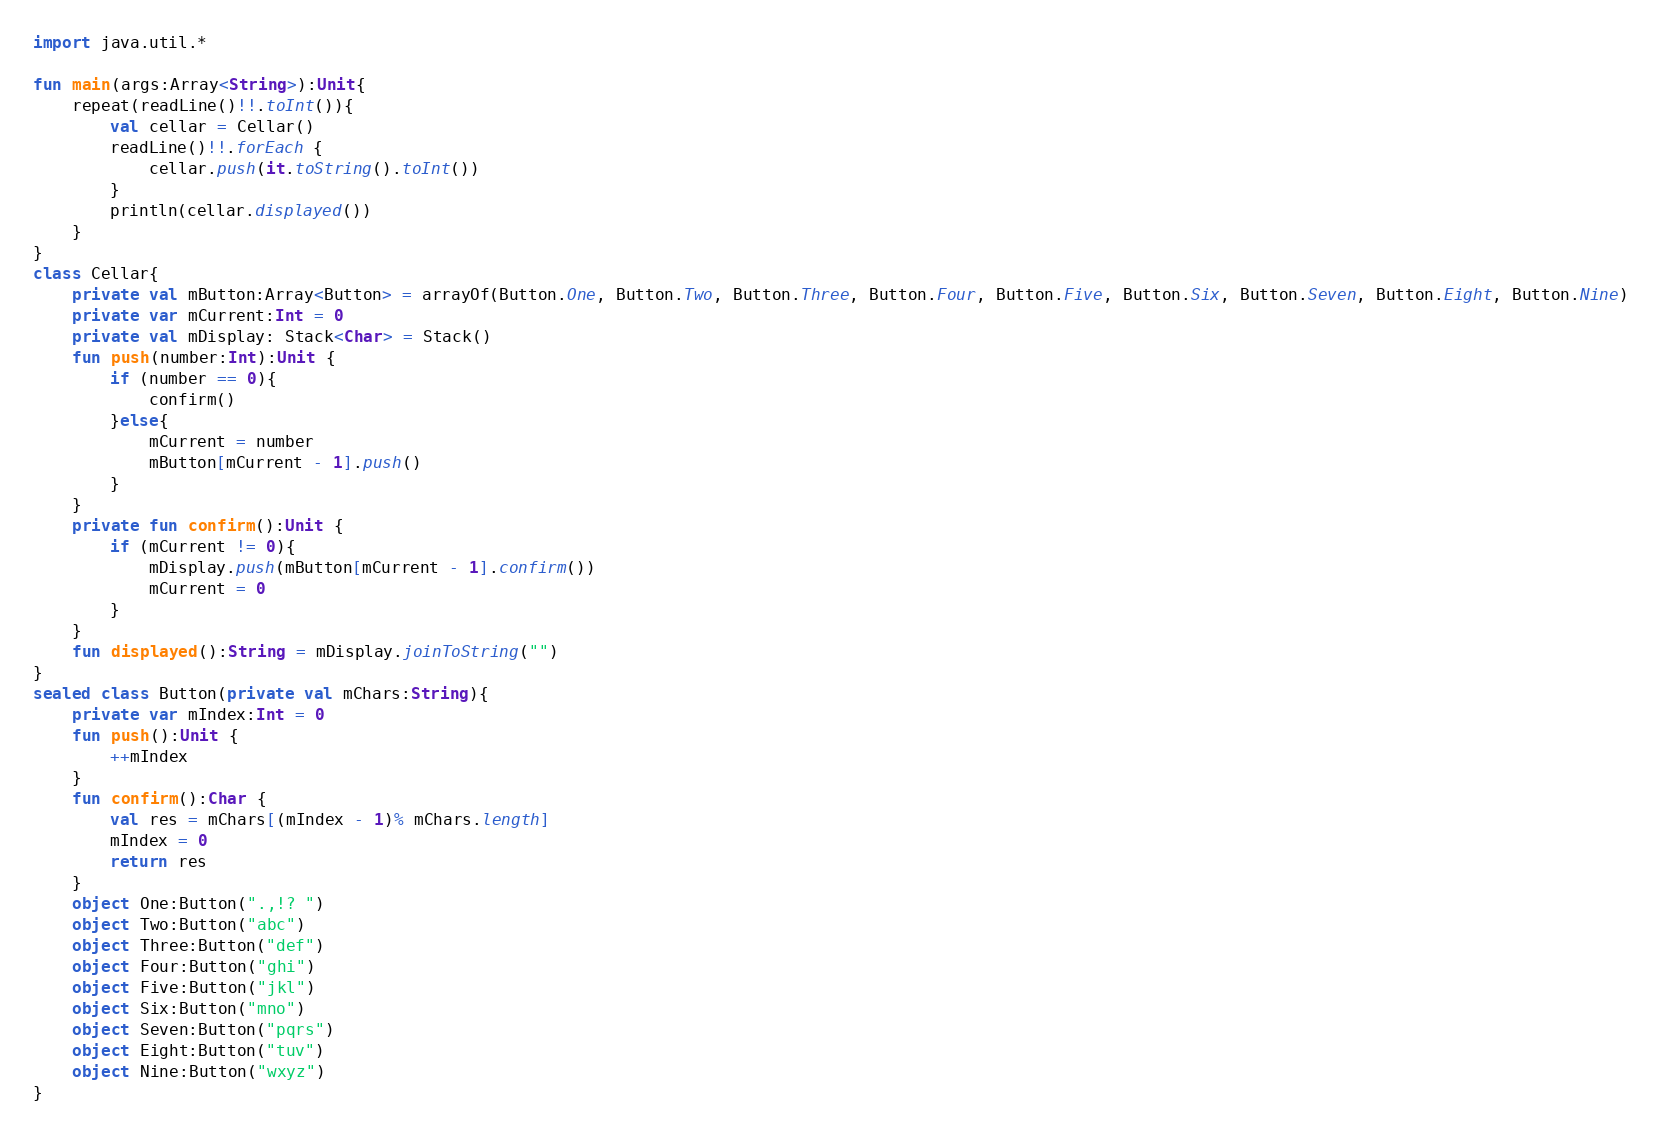<code> <loc_0><loc_0><loc_500><loc_500><_Kotlin_>import java.util.*

fun main(args:Array<String>):Unit{
    repeat(readLine()!!.toInt()){
        val cellar = Cellar()
        readLine()!!.forEach {
            cellar.push(it.toString().toInt())
        }
        println(cellar.displayed())
    }
}
class Cellar{
    private val mButton:Array<Button> = arrayOf(Button.One, Button.Two, Button.Three, Button.Four, Button.Five, Button.Six, Button.Seven, Button.Eight, Button.Nine)
    private var mCurrent:Int = 0
    private val mDisplay: Stack<Char> = Stack()
    fun push(number:Int):Unit {
        if (number == 0){
            confirm()
        }else{
            mCurrent = number
            mButton[mCurrent - 1].push()
        }
    }
    private fun confirm():Unit {
        if (mCurrent != 0){
            mDisplay.push(mButton[mCurrent - 1].confirm())
            mCurrent = 0
        }
    }
    fun displayed():String = mDisplay.joinToString("")
}
sealed class Button(private val mChars:String){
    private var mIndex:Int = 0
    fun push():Unit {
        ++mIndex
    }
    fun confirm():Char {
        val res = mChars[(mIndex - 1)% mChars.length]
        mIndex = 0
        return res
    }
    object One:Button(".,!? ")
    object Two:Button("abc")
    object Three:Button("def")
    object Four:Button("ghi")
    object Five:Button("jkl")
    object Six:Button("mno")
    object Seven:Button("pqrs")
    object Eight:Button("tuv")
    object Nine:Button("wxyz")
}
</code> 